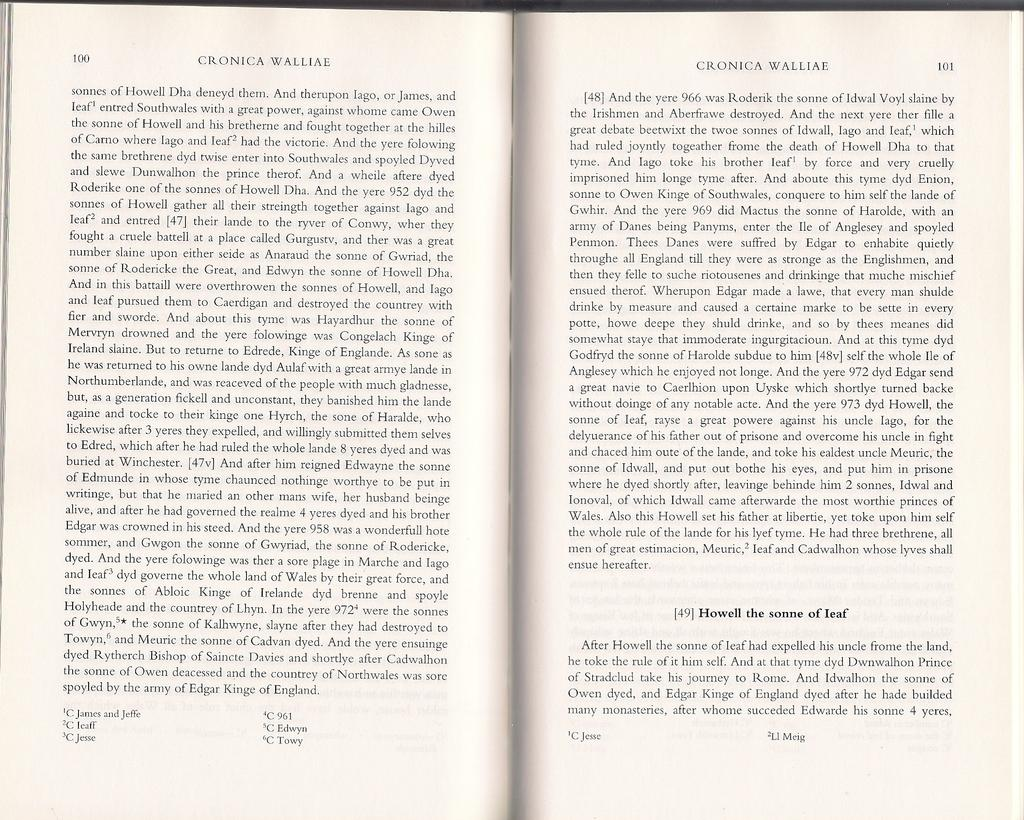<image>
Give a short and clear explanation of the subsequent image. Book open on a page that says number 101 on the top right. 